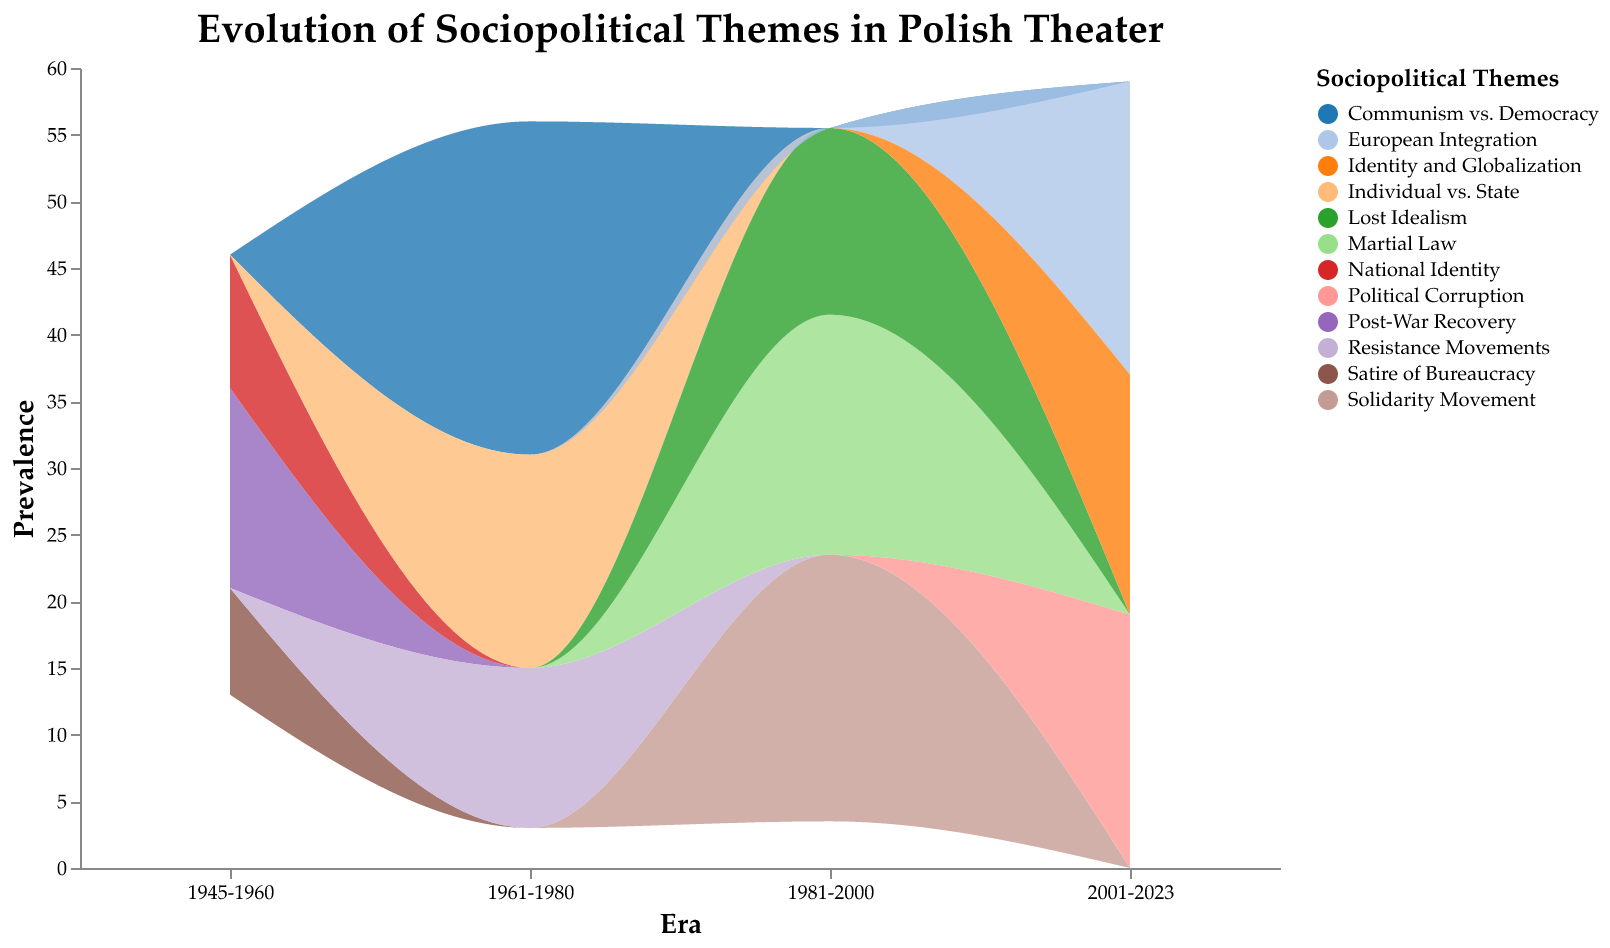What is the title of the figure? The title of the figure is specified at the top and is the main descriptor for the visualization.
Answer: Evolution of Sociopolitical Themes in Polish Theater Which era has the highest prevalence of themes in Political Drama? The era with the highest prevalence of themes in Political Drama can be identified by finding the era with the tallest area in the color representing Political Drama.
Answer: 1961-1980 What sociopolitical theme is associated with Experimental Theater in the era 1981-2000? This information can be found by looking at the specific era (1981-2000) and identifying the theme color coded for Experimental Theater.
Answer: Solidarity Movement Compare the themes in the Comedy genre between the eras 1945-1960 and 2001-2023. By examining the themes in the Comedy genre for both specified eras, we can see what themes are present and compare them. The 1945-1960 era has "Satire of Bureaucracy" and the 2001-2023 era has "Political Corruption."
Answer: 1945-1960: Satire of Bureaucracy, 2001-2023: Political Corruption Which sociopolitical theme had the highest overall prevalence in the era 1961-1980? To find this, we look at the themes present in this era and identify which has the largest represented area stacked on the graph.
Answer: Communism vs. Democracy How did the theme "National Identity" change from 1945-1960 to 1981-2000? Checking the continuation and count of the theme "National Identity" across these eras reveals that it is associated only with Romantic Drama in 1945-1960 and no longer appears in 1981-2000.
Answer: The theme "National Identity" was present in 1945-1960 but did not appear in 1981-2000 What is the sum of the prevalence of all themes in Experimental Theater for the era 2001-2023? Summing up all counts of themes in Experimental Theater for the era 2001-2023. The count for "Identity and Globalization" is 18.
Answer: 18 Identify the genre and era with the theme "Lost Idealism." By checking the theme "Lost Idealism" in the data, we see it falls under Romantic Drama in the era 1981-2000.
Answer: Genre: Romantic Drama, Era: 1981-2000 What is the difference in the prevalence of the theme "Martial Law" between the eras 1981-2000 and 2001-2023? The prevalence for "Martial Law" in 1981-2000 is 18. It does not appear in 2001-2023, so the difference = 18 - 0.
Answer: 18 